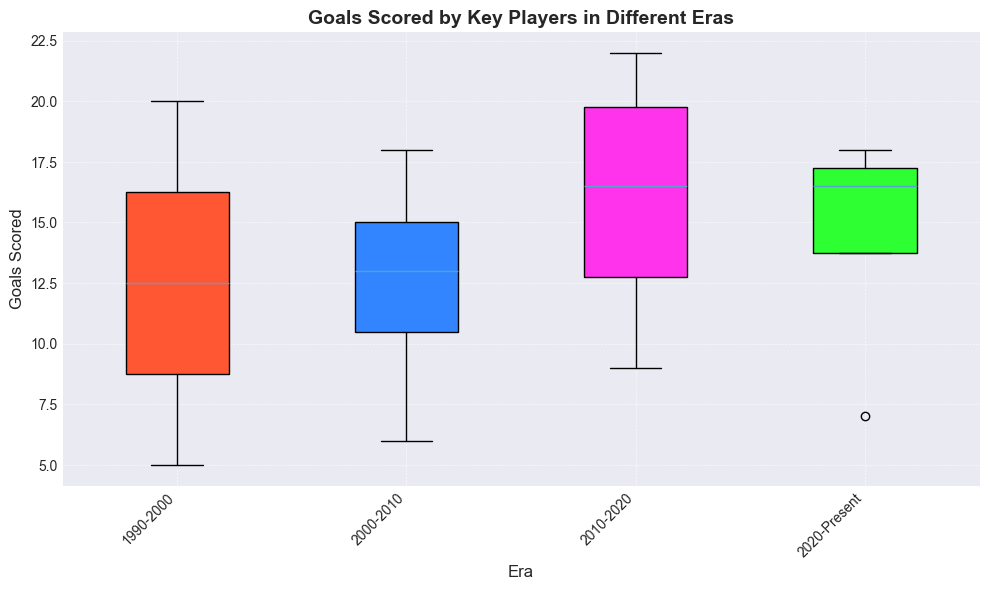What era has the highest median number of goals scored by players? To find the median number of goals for each era, observe the middle line within each box plot. The era with the highest median will have this line at the highest position.
Answer: 2010-2020 Which era's box plot has the widest range of goals scored? To determine the widest range, look at the length of the box plot—from the bottom whisker to the top whisker. The era with the longest box plot has the widest range of goals scored.
Answer: 2010-2020 What is the interquartile range (IQR) for goals scored in the 2020-Present era? The IQR is the range between the first quartile (Q1) and the third quartile (Q3). Locate the bottom and top edges of the box for the 2020-Present era to find Q1 and Q3, then subtract Q1 from Q3.
Answer: 11 Which era has the smallest median number of goals scored and what is the value? Look at the median line within each box. The era with the lowest median line has the smallest median number of goals scored. Read off the value of this line.
Answer: 1990-2000, 12.5 Compare the median goals scored in the 1990-2000 and 2000-2010 eras. Which is higher and by how much? Note the position of the median lines within each box plot for these two eras. Subtract the median of 1990-2000 from the median of 2000-2010 to find the difference.
Answer: 2000-2010 is higher by 2.5 goals What is the approximate range of goals scored by key players in the 1990-2000 era? To find the range, observe the lowest and highest points (whiskers) of the box plot for the 1990-2000 era. Subtract the lowest point from the highest point.
Answer: 15 Are there any outliers in the number of goals scored for any era? Outliers are typically represented as individual points outside the whiskers of the box plots. Look for any such points in the plots for all eras.
Answer: No Which era has the tallest box (indicating the largest IQR) and what does this suggest about the goals scored by players in that era? Measure the height of each box. The era with the tallest box has the largest IQR, indicating greater variability in goals scored by players in that era.
Answer: 2010-2020, suggesting greater variability How does the variability of goals scored in the 2000-2010 era compare to the 2020-Present era? Variability can be observed by comparing the heights of the boxes and the lengths of the whiskers. Determine which era has a taller box and longer whiskers to identify greater variability.
Answer: 2000-2010 has less variability What can be inferred about the performance of players in the 2020-Present era based on the box plot? Examine the position of the box, whiskers, and any potential outliers. Consider the median, IQR, range, and any special data points. The higher median and relatively smaller IQR suggest consistent performance with higher average goals scored.
Answer: Consistent with higher average goals 